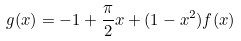<formula> <loc_0><loc_0><loc_500><loc_500>g ( x ) = - 1 + \frac { \pi } { 2 } x + ( 1 - x ^ { 2 } ) f ( x )</formula> 